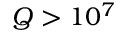<formula> <loc_0><loc_0><loc_500><loc_500>Q > 1 0 ^ { 7 }</formula> 